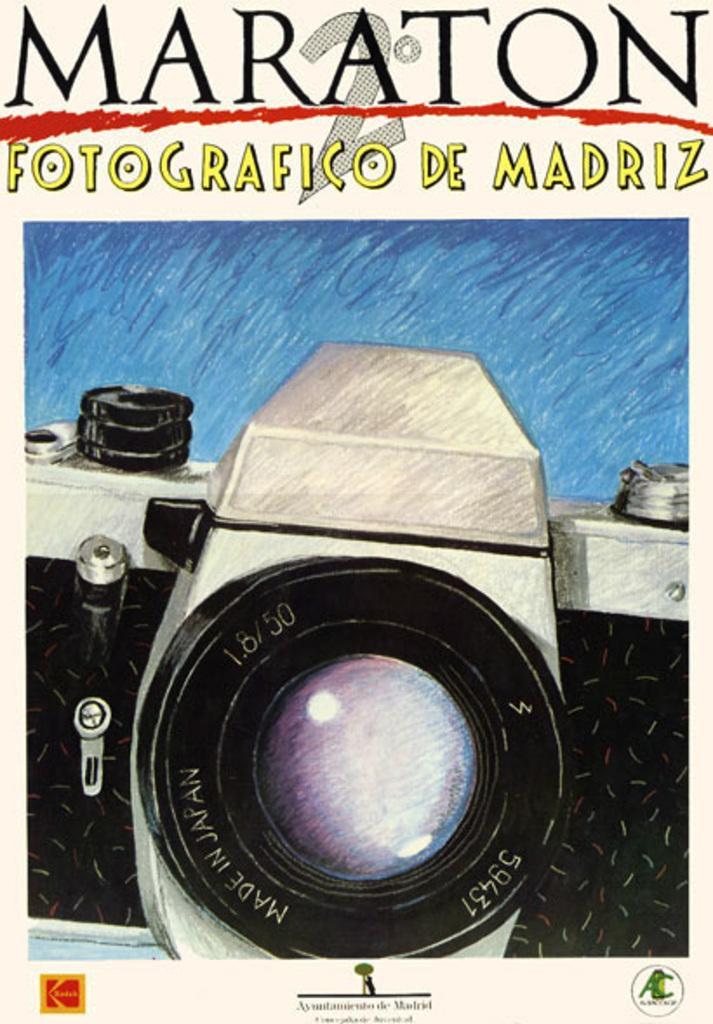Can you describe this image briefly? In this image we can see a poster with the text, logos and also the camera. 